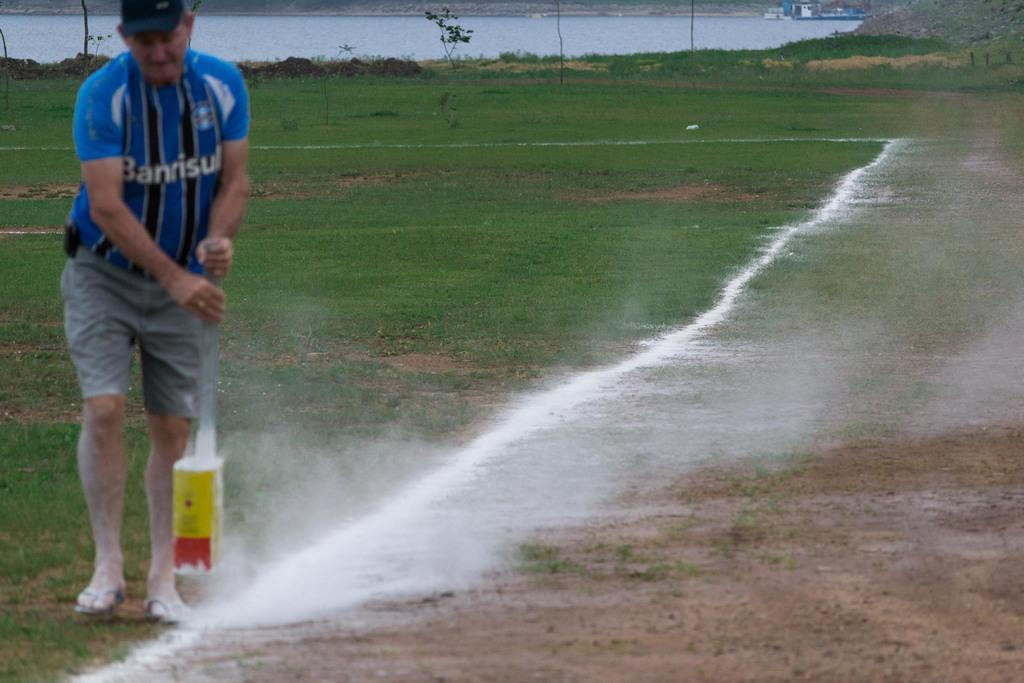<image>
Render a clear and concise summary of the photo. A man in a Banrisul striped shirt making a chalk line along a field. 